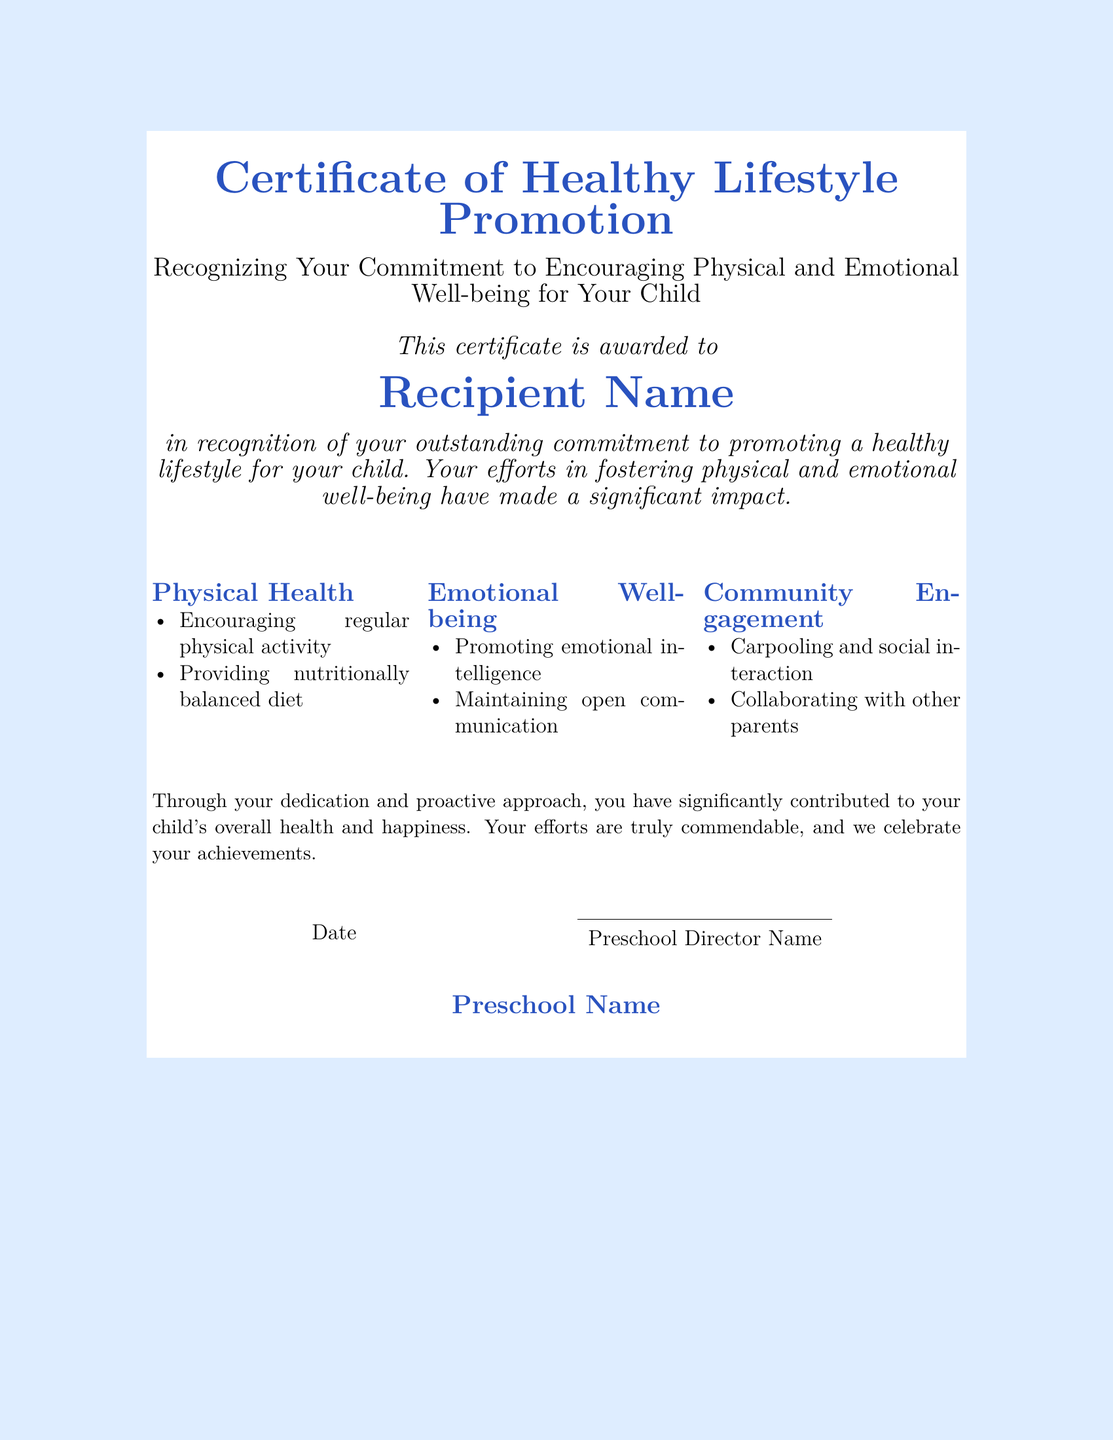What is the title of the certificate? The title of the certificate is provided at the top of the document and indicates its purpose, which is to recognize efforts in promoting a healthy lifestyle.
Answer: Certificate of Healthy Lifestyle Promotion Who is the recipient of the certificate? The recipient's name is mentioned in the document as the individual being recognized.
Answer: Recipient Name What are two aspects of physical health mentioned? The certificate lists specific efforts that contribute to physical health under the relevant section; these aspects reflect the initiatives taken by the recipient.
Answer: Encouraging regular physical activity, Providing nutritionally balanced diet What is emphasized under emotional well-being? The document outlines important qualities that contribute to a child's emotional health, which the recipient is acknowledged for promoting.
Answer: Promoting emotional intelligence, Maintaining open communication What role does community engagement play in this recognition? Community engagement is highlighted in the document as part of the efforts recognized in the certificate, showing the importance of cooperation among parents.
Answer: Carpooling and social interaction, Collaborating with other parents What is the significance of the date mentioned? The date serves to document when the certificate was awarded, which is a standard practice for official recognition of achievements.
Answer: Date Who signs the certificate? The document specifies a name that authorizes and legitimizes the recognition provided within the certificate, indicating the authority of the signatory.
Answer: Preschool Director Name What is the purpose of the certificate? The certificate is designed to formally acknowledge and celebrate the efforts made by the recipient in promoting their child's health and well-being.
Answer: Recognizing Your Commitment to Encouraging Physical and Emotional Well-being for Your Child 